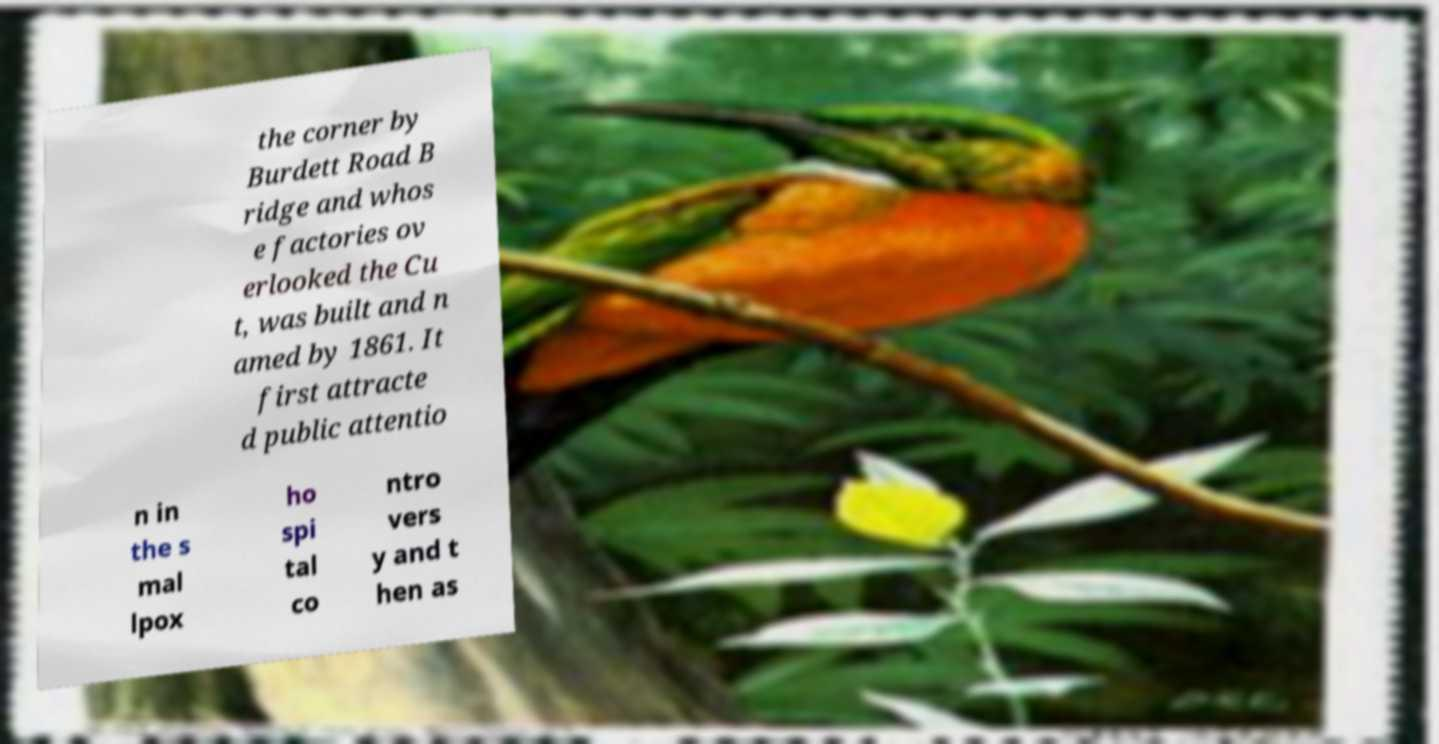I need the written content from this picture converted into text. Can you do that? the corner by Burdett Road B ridge and whos e factories ov erlooked the Cu t, was built and n amed by 1861. It first attracte d public attentio n in the s mal lpox ho spi tal co ntro vers y and t hen as 